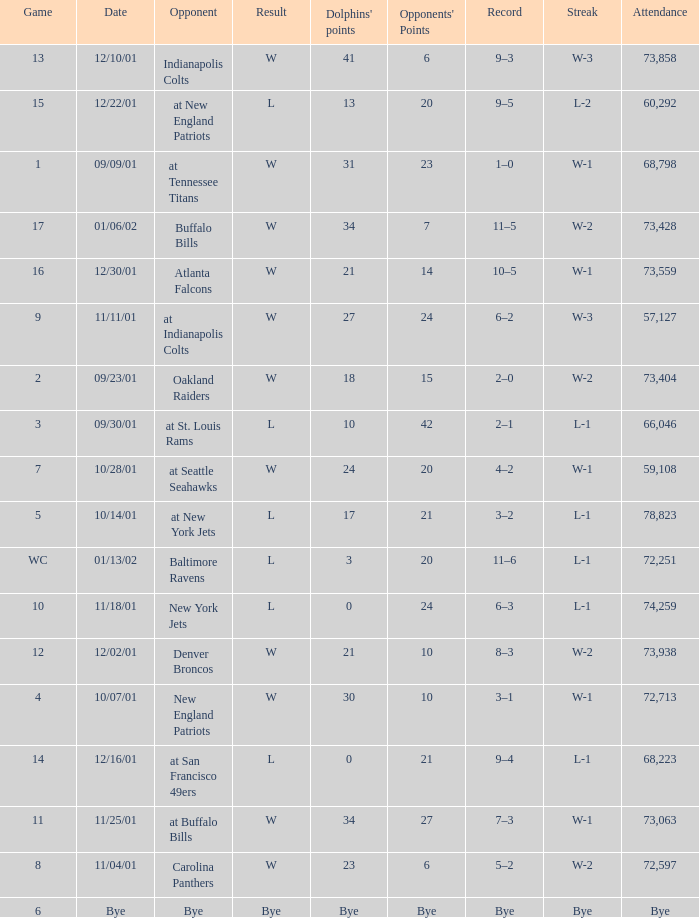How many opponents points were there on 11/11/01? 24.0. 